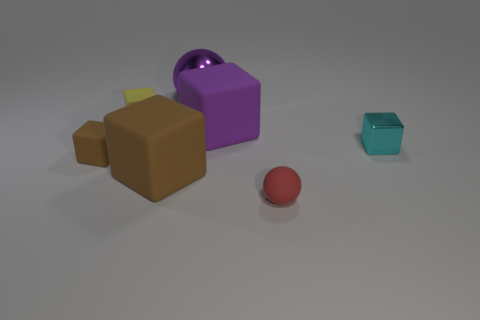Subtract 1 blocks. How many blocks are left? 4 Subtract all yellow cubes. How many cubes are left? 4 Subtract all tiny cyan cubes. How many cubes are left? 4 Add 3 small blue rubber blocks. How many objects exist? 10 Subtract all purple blocks. Subtract all green cylinders. How many blocks are left? 4 Subtract all spheres. How many objects are left? 5 Subtract 0 red cylinders. How many objects are left? 7 Subtract all large blue metallic spheres. Subtract all small yellow things. How many objects are left? 6 Add 6 purple shiny objects. How many purple shiny objects are left? 7 Add 5 purple spheres. How many purple spheres exist? 6 